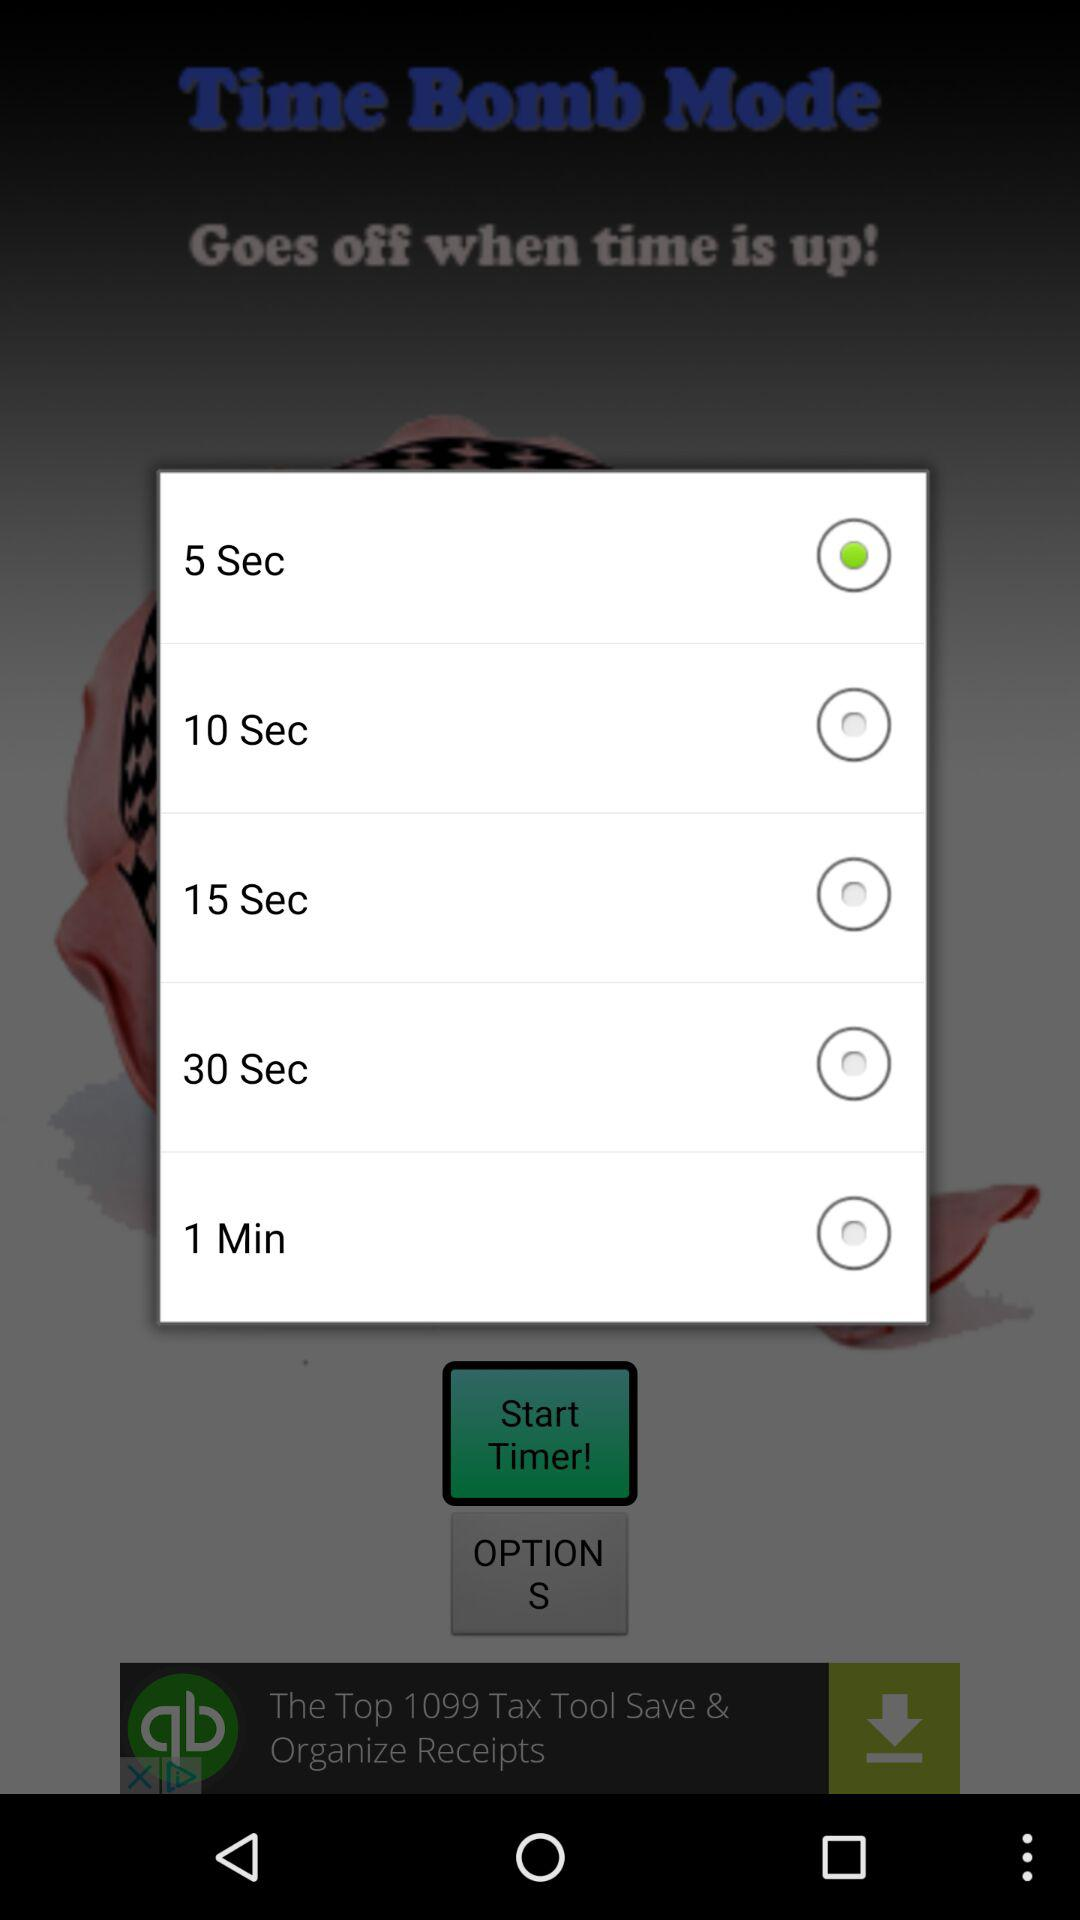How many seconds are there in the shortest duration option?
Answer the question using a single word or phrase. 5 